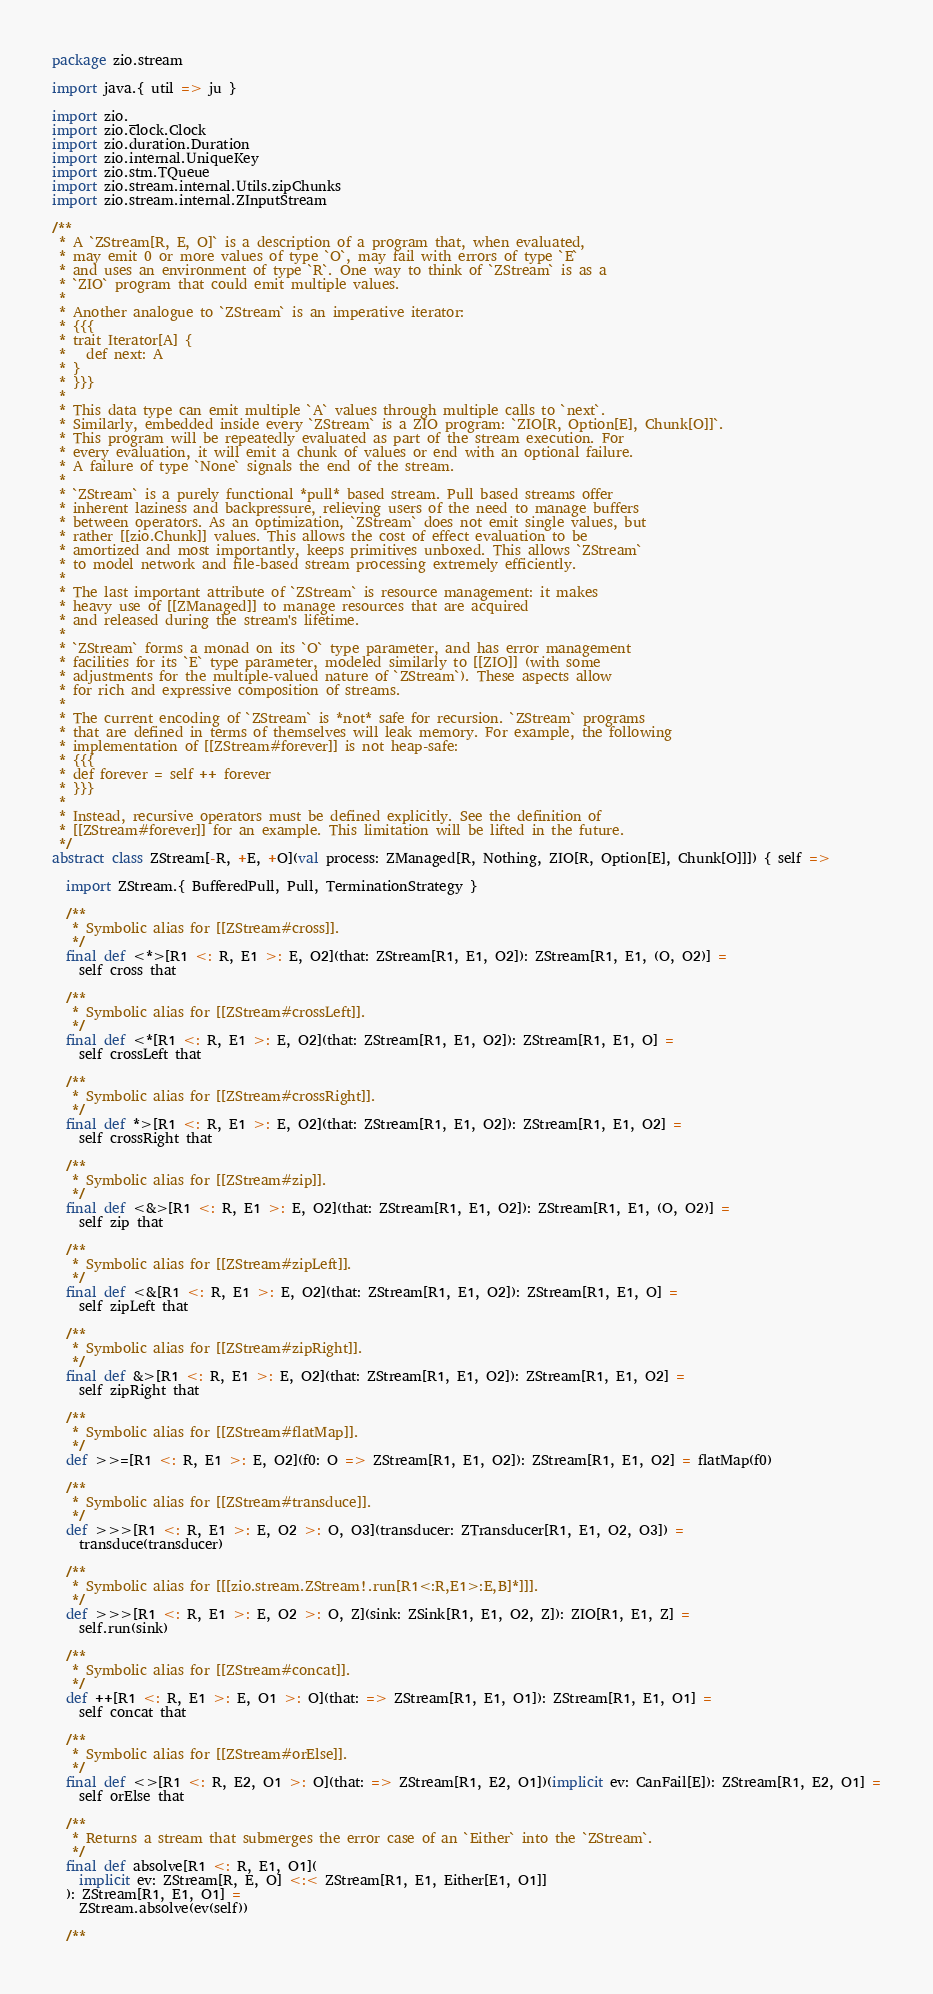Convert code to text. <code><loc_0><loc_0><loc_500><loc_500><_Scala_>package zio.stream

import java.{ util => ju }

import zio._
import zio.clock.Clock
import zio.duration.Duration
import zio.internal.UniqueKey
import zio.stm.TQueue
import zio.stream.internal.Utils.zipChunks
import zio.stream.internal.ZInputStream

/**
 * A `ZStream[R, E, O]` is a description of a program that, when evaluated,
 * may emit 0 or more values of type `O`, may fail with errors of type `E`
 * and uses an environment of type `R`. One way to think of `ZStream` is as a
 * `ZIO` program that could emit multiple values.
 *
 * Another analogue to `ZStream` is an imperative iterator:
 * {{{
 * trait Iterator[A] {
 *   def next: A
 * }
 * }}}
 *
 * This data type can emit multiple `A` values through multiple calls to `next`.
 * Similarly, embedded inside every `ZStream` is a ZIO program: `ZIO[R, Option[E], Chunk[O]]`.
 * This program will be repeatedly evaluated as part of the stream execution. For
 * every evaluation, it will emit a chunk of values or end with an optional failure.
 * A failure of type `None` signals the end of the stream.
 *
 * `ZStream` is a purely functional *pull* based stream. Pull based streams offer
 * inherent laziness and backpressure, relieving users of the need to manage buffers
 * between operators. As an optimization, `ZStream` does not emit single values, but
 * rather [[zio.Chunk]] values. This allows the cost of effect evaluation to be
 * amortized and most importantly, keeps primitives unboxed. This allows `ZStream`
 * to model network and file-based stream processing extremely efficiently.
 *
 * The last important attribute of `ZStream` is resource management: it makes
 * heavy use of [[ZManaged]] to manage resources that are acquired
 * and released during the stream's lifetime.
 *
 * `ZStream` forms a monad on its `O` type parameter, and has error management
 * facilities for its `E` type parameter, modeled similarly to [[ZIO]] (with some
 * adjustments for the multiple-valued nature of `ZStream`). These aspects allow
 * for rich and expressive composition of streams.
 *
 * The current encoding of `ZStream` is *not* safe for recursion. `ZStream` programs
 * that are defined in terms of themselves will leak memory. For example, the following
 * implementation of [[ZStream#forever]] is not heap-safe:
 * {{{
 * def forever = self ++ forever
 * }}}
 *
 * Instead, recursive operators must be defined explicitly. See the definition of
 * [[ZStream#forever]] for an example. This limitation will be lifted in the future.
 */
abstract class ZStream[-R, +E, +O](val process: ZManaged[R, Nothing, ZIO[R, Option[E], Chunk[O]]]) { self =>

  import ZStream.{ BufferedPull, Pull, TerminationStrategy }

  /**
   * Symbolic alias for [[ZStream#cross]].
   */
  final def <*>[R1 <: R, E1 >: E, O2](that: ZStream[R1, E1, O2]): ZStream[R1, E1, (O, O2)] =
    self cross that

  /**
   * Symbolic alias for [[ZStream#crossLeft]].
   */
  final def <*[R1 <: R, E1 >: E, O2](that: ZStream[R1, E1, O2]): ZStream[R1, E1, O] =
    self crossLeft that

  /**
   * Symbolic alias for [[ZStream#crossRight]].
   */
  final def *>[R1 <: R, E1 >: E, O2](that: ZStream[R1, E1, O2]): ZStream[R1, E1, O2] =
    self crossRight that

  /**
   * Symbolic alias for [[ZStream#zip]].
   */
  final def <&>[R1 <: R, E1 >: E, O2](that: ZStream[R1, E1, O2]): ZStream[R1, E1, (O, O2)] =
    self zip that

  /**
   * Symbolic alias for [[ZStream#zipLeft]].
   */
  final def <&[R1 <: R, E1 >: E, O2](that: ZStream[R1, E1, O2]): ZStream[R1, E1, O] =
    self zipLeft that

  /**
   * Symbolic alias for [[ZStream#zipRight]].
   */
  final def &>[R1 <: R, E1 >: E, O2](that: ZStream[R1, E1, O2]): ZStream[R1, E1, O2] =
    self zipRight that

  /**
   * Symbolic alias for [[ZStream#flatMap]].
   */
  def >>=[R1 <: R, E1 >: E, O2](f0: O => ZStream[R1, E1, O2]): ZStream[R1, E1, O2] = flatMap(f0)

  /**
   * Symbolic alias for [[ZStream#transduce]].
   */
  def >>>[R1 <: R, E1 >: E, O2 >: O, O3](transducer: ZTransducer[R1, E1, O2, O3]) =
    transduce(transducer)

  /**
   * Symbolic alias for [[[zio.stream.ZStream!.run[R1<:R,E1>:E,B]*]]].
   */
  def >>>[R1 <: R, E1 >: E, O2 >: O, Z](sink: ZSink[R1, E1, O2, Z]): ZIO[R1, E1, Z] =
    self.run(sink)

  /**
   * Symbolic alias for [[ZStream#concat]].
   */
  def ++[R1 <: R, E1 >: E, O1 >: O](that: => ZStream[R1, E1, O1]): ZStream[R1, E1, O1] =
    self concat that

  /**
   * Symbolic alias for [[ZStream#orElse]].
   */
  final def <>[R1 <: R, E2, O1 >: O](that: => ZStream[R1, E2, O1])(implicit ev: CanFail[E]): ZStream[R1, E2, O1] =
    self orElse that

  /**
   * Returns a stream that submerges the error case of an `Either` into the `ZStream`.
   */
  final def absolve[R1 <: R, E1, O1](
    implicit ev: ZStream[R, E, O] <:< ZStream[R1, E1, Either[E1, O1]]
  ): ZStream[R1, E1, O1] =
    ZStream.absolve(ev(self))

  /**</code> 